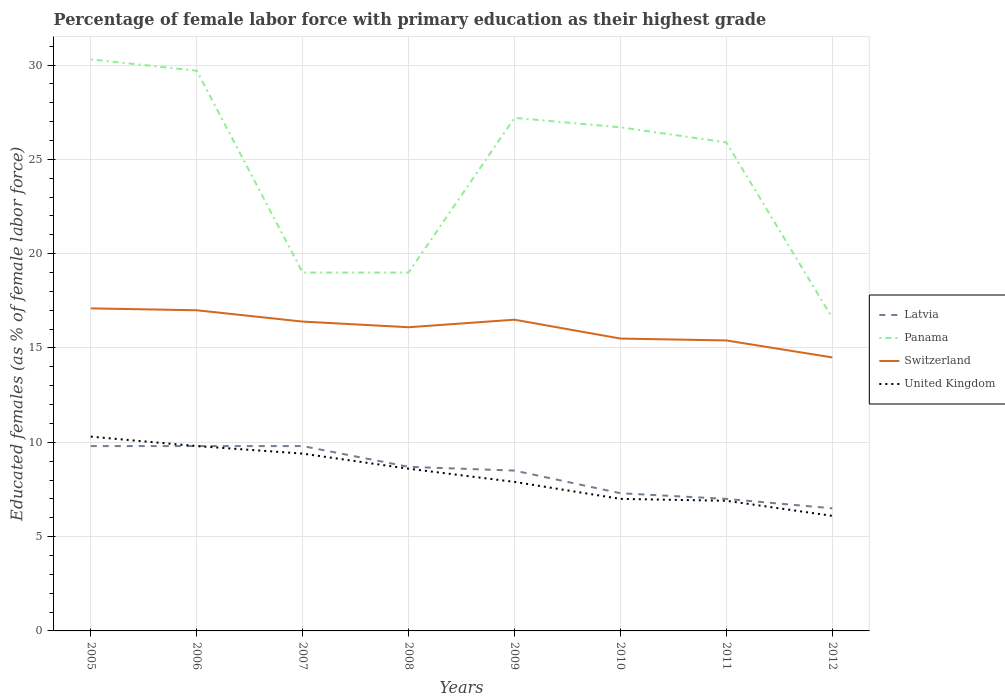How many different coloured lines are there?
Keep it short and to the point. 4. Across all years, what is the maximum percentage of female labor force with primary education in United Kingdom?
Make the answer very short. 6.1. What is the total percentage of female labor force with primary education in United Kingdom in the graph?
Your answer should be very brief. 1.2. What is the difference between the highest and the second highest percentage of female labor force with primary education in Latvia?
Keep it short and to the point. 3.3. What is the difference between the highest and the lowest percentage of female labor force with primary education in United Kingdom?
Your answer should be very brief. 4. How many lines are there?
Give a very brief answer. 4. Are the values on the major ticks of Y-axis written in scientific E-notation?
Your response must be concise. No. Does the graph contain any zero values?
Ensure brevity in your answer.  No. How are the legend labels stacked?
Your response must be concise. Vertical. What is the title of the graph?
Keep it short and to the point. Percentage of female labor force with primary education as their highest grade. Does "Honduras" appear as one of the legend labels in the graph?
Make the answer very short. No. What is the label or title of the X-axis?
Provide a short and direct response. Years. What is the label or title of the Y-axis?
Your answer should be very brief. Educated females (as % of female labor force). What is the Educated females (as % of female labor force) in Latvia in 2005?
Keep it short and to the point. 9.8. What is the Educated females (as % of female labor force) in Panama in 2005?
Offer a very short reply. 30.3. What is the Educated females (as % of female labor force) in Switzerland in 2005?
Give a very brief answer. 17.1. What is the Educated females (as % of female labor force) in United Kingdom in 2005?
Ensure brevity in your answer.  10.3. What is the Educated females (as % of female labor force) of Latvia in 2006?
Give a very brief answer. 9.8. What is the Educated females (as % of female labor force) of Panama in 2006?
Ensure brevity in your answer.  29.7. What is the Educated females (as % of female labor force) in United Kingdom in 2006?
Offer a terse response. 9.8. What is the Educated females (as % of female labor force) of Latvia in 2007?
Provide a short and direct response. 9.8. What is the Educated females (as % of female labor force) in Switzerland in 2007?
Your answer should be very brief. 16.4. What is the Educated females (as % of female labor force) of United Kingdom in 2007?
Provide a short and direct response. 9.4. What is the Educated females (as % of female labor force) in Latvia in 2008?
Ensure brevity in your answer.  8.7. What is the Educated females (as % of female labor force) of Panama in 2008?
Give a very brief answer. 19. What is the Educated females (as % of female labor force) of Switzerland in 2008?
Make the answer very short. 16.1. What is the Educated females (as % of female labor force) in United Kingdom in 2008?
Give a very brief answer. 8.6. What is the Educated females (as % of female labor force) of Latvia in 2009?
Your response must be concise. 8.5. What is the Educated females (as % of female labor force) of Panama in 2009?
Provide a succinct answer. 27.2. What is the Educated females (as % of female labor force) of United Kingdom in 2009?
Your response must be concise. 7.9. What is the Educated females (as % of female labor force) of Latvia in 2010?
Ensure brevity in your answer.  7.3. What is the Educated females (as % of female labor force) of Panama in 2010?
Your answer should be very brief. 26.7. What is the Educated females (as % of female labor force) of United Kingdom in 2010?
Your answer should be very brief. 7. What is the Educated females (as % of female labor force) of Latvia in 2011?
Offer a terse response. 7. What is the Educated females (as % of female labor force) in Panama in 2011?
Offer a terse response. 25.9. What is the Educated females (as % of female labor force) of Switzerland in 2011?
Offer a terse response. 15.4. What is the Educated females (as % of female labor force) in United Kingdom in 2011?
Provide a succinct answer. 6.9. What is the Educated females (as % of female labor force) in Panama in 2012?
Ensure brevity in your answer.  16.6. What is the Educated females (as % of female labor force) of Switzerland in 2012?
Your response must be concise. 14.5. What is the Educated females (as % of female labor force) of United Kingdom in 2012?
Keep it short and to the point. 6.1. Across all years, what is the maximum Educated females (as % of female labor force) in Latvia?
Offer a terse response. 9.8. Across all years, what is the maximum Educated females (as % of female labor force) of Panama?
Your answer should be very brief. 30.3. Across all years, what is the maximum Educated females (as % of female labor force) of Switzerland?
Your answer should be very brief. 17.1. Across all years, what is the maximum Educated females (as % of female labor force) in United Kingdom?
Give a very brief answer. 10.3. Across all years, what is the minimum Educated females (as % of female labor force) of Latvia?
Offer a terse response. 6.5. Across all years, what is the minimum Educated females (as % of female labor force) of Panama?
Offer a very short reply. 16.6. Across all years, what is the minimum Educated females (as % of female labor force) in United Kingdom?
Your response must be concise. 6.1. What is the total Educated females (as % of female labor force) in Latvia in the graph?
Keep it short and to the point. 67.4. What is the total Educated females (as % of female labor force) of Panama in the graph?
Provide a short and direct response. 194.4. What is the total Educated females (as % of female labor force) of Switzerland in the graph?
Provide a succinct answer. 128.5. What is the total Educated females (as % of female labor force) of United Kingdom in the graph?
Ensure brevity in your answer.  66. What is the difference between the Educated females (as % of female labor force) of Panama in 2005 and that in 2006?
Give a very brief answer. 0.6. What is the difference between the Educated females (as % of female labor force) in United Kingdom in 2005 and that in 2006?
Offer a very short reply. 0.5. What is the difference between the Educated females (as % of female labor force) in Panama in 2005 and that in 2007?
Provide a short and direct response. 11.3. What is the difference between the Educated females (as % of female labor force) in United Kingdom in 2005 and that in 2007?
Provide a short and direct response. 0.9. What is the difference between the Educated females (as % of female labor force) in Switzerland in 2005 and that in 2010?
Give a very brief answer. 1.6. What is the difference between the Educated females (as % of female labor force) in United Kingdom in 2005 and that in 2010?
Your answer should be compact. 3.3. What is the difference between the Educated females (as % of female labor force) in Latvia in 2005 and that in 2011?
Ensure brevity in your answer.  2.8. What is the difference between the Educated females (as % of female labor force) in Switzerland in 2005 and that in 2012?
Give a very brief answer. 2.6. What is the difference between the Educated females (as % of female labor force) in United Kingdom in 2005 and that in 2012?
Keep it short and to the point. 4.2. What is the difference between the Educated females (as % of female labor force) of Latvia in 2006 and that in 2007?
Your answer should be very brief. 0. What is the difference between the Educated females (as % of female labor force) of Panama in 2006 and that in 2007?
Offer a very short reply. 10.7. What is the difference between the Educated females (as % of female labor force) in Switzerland in 2006 and that in 2007?
Offer a very short reply. 0.6. What is the difference between the Educated females (as % of female labor force) of Latvia in 2006 and that in 2008?
Offer a terse response. 1.1. What is the difference between the Educated females (as % of female labor force) in Panama in 2006 and that in 2008?
Keep it short and to the point. 10.7. What is the difference between the Educated females (as % of female labor force) in Panama in 2006 and that in 2010?
Your answer should be compact. 3. What is the difference between the Educated females (as % of female labor force) of Switzerland in 2006 and that in 2010?
Give a very brief answer. 1.5. What is the difference between the Educated females (as % of female labor force) in Panama in 2006 and that in 2011?
Offer a terse response. 3.8. What is the difference between the Educated females (as % of female labor force) in Switzerland in 2006 and that in 2011?
Keep it short and to the point. 1.6. What is the difference between the Educated females (as % of female labor force) of Panama in 2006 and that in 2012?
Make the answer very short. 13.1. What is the difference between the Educated females (as % of female labor force) in Switzerland in 2007 and that in 2008?
Your answer should be very brief. 0.3. What is the difference between the Educated females (as % of female labor force) in United Kingdom in 2007 and that in 2008?
Your answer should be very brief. 0.8. What is the difference between the Educated females (as % of female labor force) in Panama in 2007 and that in 2009?
Provide a short and direct response. -8.2. What is the difference between the Educated females (as % of female labor force) in United Kingdom in 2007 and that in 2009?
Your answer should be very brief. 1.5. What is the difference between the Educated females (as % of female labor force) in Panama in 2007 and that in 2010?
Provide a succinct answer. -7.7. What is the difference between the Educated females (as % of female labor force) of Switzerland in 2007 and that in 2010?
Make the answer very short. 0.9. What is the difference between the Educated females (as % of female labor force) of Panama in 2007 and that in 2011?
Your response must be concise. -6.9. What is the difference between the Educated females (as % of female labor force) in Panama in 2007 and that in 2012?
Your response must be concise. 2.4. What is the difference between the Educated females (as % of female labor force) in Panama in 2008 and that in 2009?
Provide a succinct answer. -8.2. What is the difference between the Educated females (as % of female labor force) in Switzerland in 2008 and that in 2009?
Keep it short and to the point. -0.4. What is the difference between the Educated females (as % of female labor force) of United Kingdom in 2008 and that in 2009?
Your response must be concise. 0.7. What is the difference between the Educated females (as % of female labor force) of Panama in 2008 and that in 2010?
Provide a short and direct response. -7.7. What is the difference between the Educated females (as % of female labor force) of United Kingdom in 2008 and that in 2010?
Keep it short and to the point. 1.6. What is the difference between the Educated females (as % of female labor force) in Panama in 2008 and that in 2011?
Provide a short and direct response. -6.9. What is the difference between the Educated females (as % of female labor force) of Switzerland in 2008 and that in 2011?
Ensure brevity in your answer.  0.7. What is the difference between the Educated females (as % of female labor force) of Latvia in 2008 and that in 2012?
Offer a terse response. 2.2. What is the difference between the Educated females (as % of female labor force) in United Kingdom in 2008 and that in 2012?
Your response must be concise. 2.5. What is the difference between the Educated females (as % of female labor force) in Latvia in 2009 and that in 2010?
Keep it short and to the point. 1.2. What is the difference between the Educated females (as % of female labor force) of Panama in 2009 and that in 2010?
Make the answer very short. 0.5. What is the difference between the Educated females (as % of female labor force) of Switzerland in 2009 and that in 2010?
Provide a succinct answer. 1. What is the difference between the Educated females (as % of female labor force) of Panama in 2009 and that in 2011?
Your answer should be compact. 1.3. What is the difference between the Educated females (as % of female labor force) in United Kingdom in 2009 and that in 2011?
Make the answer very short. 1. What is the difference between the Educated females (as % of female labor force) in Latvia in 2009 and that in 2012?
Your response must be concise. 2. What is the difference between the Educated females (as % of female labor force) of Panama in 2009 and that in 2012?
Your response must be concise. 10.6. What is the difference between the Educated females (as % of female labor force) in United Kingdom in 2009 and that in 2012?
Make the answer very short. 1.8. What is the difference between the Educated females (as % of female labor force) in Latvia in 2010 and that in 2011?
Provide a succinct answer. 0.3. What is the difference between the Educated females (as % of female labor force) in United Kingdom in 2010 and that in 2011?
Offer a very short reply. 0.1. What is the difference between the Educated females (as % of female labor force) in Latvia in 2010 and that in 2012?
Ensure brevity in your answer.  0.8. What is the difference between the Educated females (as % of female labor force) of United Kingdom in 2010 and that in 2012?
Your answer should be compact. 0.9. What is the difference between the Educated females (as % of female labor force) of Latvia in 2011 and that in 2012?
Offer a very short reply. 0.5. What is the difference between the Educated females (as % of female labor force) of Panama in 2011 and that in 2012?
Your response must be concise. 9.3. What is the difference between the Educated females (as % of female labor force) of United Kingdom in 2011 and that in 2012?
Give a very brief answer. 0.8. What is the difference between the Educated females (as % of female labor force) in Latvia in 2005 and the Educated females (as % of female labor force) in Panama in 2006?
Make the answer very short. -19.9. What is the difference between the Educated females (as % of female labor force) in Panama in 2005 and the Educated females (as % of female labor force) in Switzerland in 2006?
Give a very brief answer. 13.3. What is the difference between the Educated females (as % of female labor force) of Panama in 2005 and the Educated females (as % of female labor force) of United Kingdom in 2006?
Your answer should be very brief. 20.5. What is the difference between the Educated females (as % of female labor force) in Latvia in 2005 and the Educated females (as % of female labor force) in Panama in 2007?
Offer a very short reply. -9.2. What is the difference between the Educated females (as % of female labor force) of Latvia in 2005 and the Educated females (as % of female labor force) of Switzerland in 2007?
Your answer should be very brief. -6.6. What is the difference between the Educated females (as % of female labor force) in Latvia in 2005 and the Educated females (as % of female labor force) in United Kingdom in 2007?
Keep it short and to the point. 0.4. What is the difference between the Educated females (as % of female labor force) in Panama in 2005 and the Educated females (as % of female labor force) in Switzerland in 2007?
Offer a terse response. 13.9. What is the difference between the Educated females (as % of female labor force) of Panama in 2005 and the Educated females (as % of female labor force) of United Kingdom in 2007?
Your answer should be compact. 20.9. What is the difference between the Educated females (as % of female labor force) of Switzerland in 2005 and the Educated females (as % of female labor force) of United Kingdom in 2007?
Make the answer very short. 7.7. What is the difference between the Educated females (as % of female labor force) in Panama in 2005 and the Educated females (as % of female labor force) in United Kingdom in 2008?
Offer a terse response. 21.7. What is the difference between the Educated females (as % of female labor force) in Switzerland in 2005 and the Educated females (as % of female labor force) in United Kingdom in 2008?
Give a very brief answer. 8.5. What is the difference between the Educated females (as % of female labor force) in Latvia in 2005 and the Educated females (as % of female labor force) in Panama in 2009?
Provide a succinct answer. -17.4. What is the difference between the Educated females (as % of female labor force) of Panama in 2005 and the Educated females (as % of female labor force) of Switzerland in 2009?
Offer a terse response. 13.8. What is the difference between the Educated females (as % of female labor force) of Panama in 2005 and the Educated females (as % of female labor force) of United Kingdom in 2009?
Make the answer very short. 22.4. What is the difference between the Educated females (as % of female labor force) in Switzerland in 2005 and the Educated females (as % of female labor force) in United Kingdom in 2009?
Offer a very short reply. 9.2. What is the difference between the Educated females (as % of female labor force) of Latvia in 2005 and the Educated females (as % of female labor force) of Panama in 2010?
Your answer should be compact. -16.9. What is the difference between the Educated females (as % of female labor force) in Latvia in 2005 and the Educated females (as % of female labor force) in Switzerland in 2010?
Keep it short and to the point. -5.7. What is the difference between the Educated females (as % of female labor force) in Latvia in 2005 and the Educated females (as % of female labor force) in United Kingdom in 2010?
Give a very brief answer. 2.8. What is the difference between the Educated females (as % of female labor force) in Panama in 2005 and the Educated females (as % of female labor force) in Switzerland in 2010?
Your answer should be compact. 14.8. What is the difference between the Educated females (as % of female labor force) of Panama in 2005 and the Educated females (as % of female labor force) of United Kingdom in 2010?
Provide a short and direct response. 23.3. What is the difference between the Educated females (as % of female labor force) of Latvia in 2005 and the Educated females (as % of female labor force) of Panama in 2011?
Your answer should be compact. -16.1. What is the difference between the Educated females (as % of female labor force) of Latvia in 2005 and the Educated females (as % of female labor force) of Switzerland in 2011?
Your answer should be compact. -5.6. What is the difference between the Educated females (as % of female labor force) of Latvia in 2005 and the Educated females (as % of female labor force) of United Kingdom in 2011?
Your answer should be very brief. 2.9. What is the difference between the Educated females (as % of female labor force) of Panama in 2005 and the Educated females (as % of female labor force) of Switzerland in 2011?
Give a very brief answer. 14.9. What is the difference between the Educated females (as % of female labor force) of Panama in 2005 and the Educated females (as % of female labor force) of United Kingdom in 2011?
Offer a very short reply. 23.4. What is the difference between the Educated females (as % of female labor force) in Latvia in 2005 and the Educated females (as % of female labor force) in Switzerland in 2012?
Your response must be concise. -4.7. What is the difference between the Educated females (as % of female labor force) in Latvia in 2005 and the Educated females (as % of female labor force) in United Kingdom in 2012?
Your answer should be compact. 3.7. What is the difference between the Educated females (as % of female labor force) in Panama in 2005 and the Educated females (as % of female labor force) in United Kingdom in 2012?
Offer a very short reply. 24.2. What is the difference between the Educated females (as % of female labor force) of Latvia in 2006 and the Educated females (as % of female labor force) of Panama in 2007?
Keep it short and to the point. -9.2. What is the difference between the Educated females (as % of female labor force) in Latvia in 2006 and the Educated females (as % of female labor force) in United Kingdom in 2007?
Provide a succinct answer. 0.4. What is the difference between the Educated females (as % of female labor force) in Panama in 2006 and the Educated females (as % of female labor force) in Switzerland in 2007?
Keep it short and to the point. 13.3. What is the difference between the Educated females (as % of female labor force) in Panama in 2006 and the Educated females (as % of female labor force) in United Kingdom in 2007?
Provide a succinct answer. 20.3. What is the difference between the Educated females (as % of female labor force) in Switzerland in 2006 and the Educated females (as % of female labor force) in United Kingdom in 2007?
Provide a succinct answer. 7.6. What is the difference between the Educated females (as % of female labor force) of Latvia in 2006 and the Educated females (as % of female labor force) of Panama in 2008?
Offer a very short reply. -9.2. What is the difference between the Educated females (as % of female labor force) of Panama in 2006 and the Educated females (as % of female labor force) of United Kingdom in 2008?
Give a very brief answer. 21.1. What is the difference between the Educated females (as % of female labor force) of Latvia in 2006 and the Educated females (as % of female labor force) of Panama in 2009?
Offer a very short reply. -17.4. What is the difference between the Educated females (as % of female labor force) in Latvia in 2006 and the Educated females (as % of female labor force) in Switzerland in 2009?
Provide a short and direct response. -6.7. What is the difference between the Educated females (as % of female labor force) in Latvia in 2006 and the Educated females (as % of female labor force) in United Kingdom in 2009?
Your response must be concise. 1.9. What is the difference between the Educated females (as % of female labor force) in Panama in 2006 and the Educated females (as % of female labor force) in Switzerland in 2009?
Provide a succinct answer. 13.2. What is the difference between the Educated females (as % of female labor force) in Panama in 2006 and the Educated females (as % of female labor force) in United Kingdom in 2009?
Ensure brevity in your answer.  21.8. What is the difference between the Educated females (as % of female labor force) in Switzerland in 2006 and the Educated females (as % of female labor force) in United Kingdom in 2009?
Provide a succinct answer. 9.1. What is the difference between the Educated females (as % of female labor force) in Latvia in 2006 and the Educated females (as % of female labor force) in Panama in 2010?
Keep it short and to the point. -16.9. What is the difference between the Educated females (as % of female labor force) in Latvia in 2006 and the Educated females (as % of female labor force) in Switzerland in 2010?
Your answer should be compact. -5.7. What is the difference between the Educated females (as % of female labor force) of Panama in 2006 and the Educated females (as % of female labor force) of Switzerland in 2010?
Provide a short and direct response. 14.2. What is the difference between the Educated females (as % of female labor force) in Panama in 2006 and the Educated females (as % of female labor force) in United Kingdom in 2010?
Your answer should be very brief. 22.7. What is the difference between the Educated females (as % of female labor force) in Switzerland in 2006 and the Educated females (as % of female labor force) in United Kingdom in 2010?
Offer a very short reply. 10. What is the difference between the Educated females (as % of female labor force) in Latvia in 2006 and the Educated females (as % of female labor force) in Panama in 2011?
Give a very brief answer. -16.1. What is the difference between the Educated females (as % of female labor force) in Latvia in 2006 and the Educated females (as % of female labor force) in United Kingdom in 2011?
Provide a short and direct response. 2.9. What is the difference between the Educated females (as % of female labor force) of Panama in 2006 and the Educated females (as % of female labor force) of United Kingdom in 2011?
Make the answer very short. 22.8. What is the difference between the Educated females (as % of female labor force) in Switzerland in 2006 and the Educated females (as % of female labor force) in United Kingdom in 2011?
Make the answer very short. 10.1. What is the difference between the Educated females (as % of female labor force) in Panama in 2006 and the Educated females (as % of female labor force) in United Kingdom in 2012?
Your answer should be very brief. 23.6. What is the difference between the Educated females (as % of female labor force) in Latvia in 2007 and the Educated females (as % of female labor force) in Switzerland in 2008?
Offer a terse response. -6.3. What is the difference between the Educated females (as % of female labor force) in Latvia in 2007 and the Educated females (as % of female labor force) in United Kingdom in 2008?
Your answer should be compact. 1.2. What is the difference between the Educated females (as % of female labor force) in Panama in 2007 and the Educated females (as % of female labor force) in Switzerland in 2008?
Offer a very short reply. 2.9. What is the difference between the Educated females (as % of female labor force) of Latvia in 2007 and the Educated females (as % of female labor force) of Panama in 2009?
Keep it short and to the point. -17.4. What is the difference between the Educated females (as % of female labor force) in Latvia in 2007 and the Educated females (as % of female labor force) in Switzerland in 2009?
Offer a very short reply. -6.7. What is the difference between the Educated females (as % of female labor force) of Switzerland in 2007 and the Educated females (as % of female labor force) of United Kingdom in 2009?
Offer a terse response. 8.5. What is the difference between the Educated females (as % of female labor force) of Latvia in 2007 and the Educated females (as % of female labor force) of Panama in 2010?
Your answer should be very brief. -16.9. What is the difference between the Educated females (as % of female labor force) of Panama in 2007 and the Educated females (as % of female labor force) of Switzerland in 2010?
Provide a succinct answer. 3.5. What is the difference between the Educated females (as % of female labor force) in Panama in 2007 and the Educated females (as % of female labor force) in United Kingdom in 2010?
Offer a very short reply. 12. What is the difference between the Educated females (as % of female labor force) of Latvia in 2007 and the Educated females (as % of female labor force) of Panama in 2011?
Make the answer very short. -16.1. What is the difference between the Educated females (as % of female labor force) of Latvia in 2007 and the Educated females (as % of female labor force) of United Kingdom in 2011?
Provide a short and direct response. 2.9. What is the difference between the Educated females (as % of female labor force) of Panama in 2007 and the Educated females (as % of female labor force) of Switzerland in 2011?
Ensure brevity in your answer.  3.6. What is the difference between the Educated females (as % of female labor force) in Latvia in 2007 and the Educated females (as % of female labor force) in United Kingdom in 2012?
Provide a succinct answer. 3.7. What is the difference between the Educated females (as % of female labor force) in Panama in 2007 and the Educated females (as % of female labor force) in Switzerland in 2012?
Your answer should be very brief. 4.5. What is the difference between the Educated females (as % of female labor force) of Latvia in 2008 and the Educated females (as % of female labor force) of Panama in 2009?
Offer a very short reply. -18.5. What is the difference between the Educated females (as % of female labor force) of Latvia in 2008 and the Educated females (as % of female labor force) of Panama in 2010?
Your answer should be very brief. -18. What is the difference between the Educated females (as % of female labor force) in Latvia in 2008 and the Educated females (as % of female labor force) in United Kingdom in 2010?
Offer a very short reply. 1.7. What is the difference between the Educated females (as % of female labor force) of Panama in 2008 and the Educated females (as % of female labor force) of Switzerland in 2010?
Offer a very short reply. 3.5. What is the difference between the Educated females (as % of female labor force) in Latvia in 2008 and the Educated females (as % of female labor force) in Panama in 2011?
Offer a very short reply. -17.2. What is the difference between the Educated females (as % of female labor force) in Latvia in 2008 and the Educated females (as % of female labor force) in Switzerland in 2011?
Your answer should be very brief. -6.7. What is the difference between the Educated females (as % of female labor force) in Latvia in 2008 and the Educated females (as % of female labor force) in United Kingdom in 2011?
Your answer should be compact. 1.8. What is the difference between the Educated females (as % of female labor force) in Panama in 2008 and the Educated females (as % of female labor force) in Switzerland in 2011?
Keep it short and to the point. 3.6. What is the difference between the Educated females (as % of female labor force) of Switzerland in 2008 and the Educated females (as % of female labor force) of United Kingdom in 2011?
Keep it short and to the point. 9.2. What is the difference between the Educated females (as % of female labor force) in Latvia in 2008 and the Educated females (as % of female labor force) in Panama in 2012?
Your response must be concise. -7.9. What is the difference between the Educated females (as % of female labor force) in Latvia in 2008 and the Educated females (as % of female labor force) in Switzerland in 2012?
Keep it short and to the point. -5.8. What is the difference between the Educated females (as % of female labor force) of Latvia in 2008 and the Educated females (as % of female labor force) of United Kingdom in 2012?
Keep it short and to the point. 2.6. What is the difference between the Educated females (as % of female labor force) of Switzerland in 2008 and the Educated females (as % of female labor force) of United Kingdom in 2012?
Ensure brevity in your answer.  10. What is the difference between the Educated females (as % of female labor force) of Latvia in 2009 and the Educated females (as % of female labor force) of Panama in 2010?
Provide a short and direct response. -18.2. What is the difference between the Educated females (as % of female labor force) in Latvia in 2009 and the Educated females (as % of female labor force) in Switzerland in 2010?
Ensure brevity in your answer.  -7. What is the difference between the Educated females (as % of female labor force) in Latvia in 2009 and the Educated females (as % of female labor force) in United Kingdom in 2010?
Provide a succinct answer. 1.5. What is the difference between the Educated females (as % of female labor force) of Panama in 2009 and the Educated females (as % of female labor force) of Switzerland in 2010?
Give a very brief answer. 11.7. What is the difference between the Educated females (as % of female labor force) in Panama in 2009 and the Educated females (as % of female labor force) in United Kingdom in 2010?
Provide a short and direct response. 20.2. What is the difference between the Educated females (as % of female labor force) of Latvia in 2009 and the Educated females (as % of female labor force) of Panama in 2011?
Ensure brevity in your answer.  -17.4. What is the difference between the Educated females (as % of female labor force) in Latvia in 2009 and the Educated females (as % of female labor force) in Switzerland in 2011?
Your answer should be very brief. -6.9. What is the difference between the Educated females (as % of female labor force) in Panama in 2009 and the Educated females (as % of female labor force) in Switzerland in 2011?
Offer a very short reply. 11.8. What is the difference between the Educated females (as % of female labor force) in Panama in 2009 and the Educated females (as % of female labor force) in United Kingdom in 2011?
Offer a very short reply. 20.3. What is the difference between the Educated females (as % of female labor force) in Switzerland in 2009 and the Educated females (as % of female labor force) in United Kingdom in 2011?
Your answer should be compact. 9.6. What is the difference between the Educated females (as % of female labor force) of Panama in 2009 and the Educated females (as % of female labor force) of United Kingdom in 2012?
Provide a short and direct response. 21.1. What is the difference between the Educated females (as % of female labor force) of Switzerland in 2009 and the Educated females (as % of female labor force) of United Kingdom in 2012?
Ensure brevity in your answer.  10.4. What is the difference between the Educated females (as % of female labor force) in Latvia in 2010 and the Educated females (as % of female labor force) in Panama in 2011?
Ensure brevity in your answer.  -18.6. What is the difference between the Educated females (as % of female labor force) in Latvia in 2010 and the Educated females (as % of female labor force) in United Kingdom in 2011?
Your answer should be compact. 0.4. What is the difference between the Educated females (as % of female labor force) of Panama in 2010 and the Educated females (as % of female labor force) of United Kingdom in 2011?
Offer a terse response. 19.8. What is the difference between the Educated females (as % of female labor force) in Latvia in 2010 and the Educated females (as % of female labor force) in Switzerland in 2012?
Offer a terse response. -7.2. What is the difference between the Educated females (as % of female labor force) of Panama in 2010 and the Educated females (as % of female labor force) of Switzerland in 2012?
Offer a terse response. 12.2. What is the difference between the Educated females (as % of female labor force) in Panama in 2010 and the Educated females (as % of female labor force) in United Kingdom in 2012?
Keep it short and to the point. 20.6. What is the difference between the Educated females (as % of female labor force) of Latvia in 2011 and the Educated females (as % of female labor force) of Switzerland in 2012?
Give a very brief answer. -7.5. What is the difference between the Educated females (as % of female labor force) in Latvia in 2011 and the Educated females (as % of female labor force) in United Kingdom in 2012?
Make the answer very short. 0.9. What is the difference between the Educated females (as % of female labor force) in Panama in 2011 and the Educated females (as % of female labor force) in Switzerland in 2012?
Give a very brief answer. 11.4. What is the difference between the Educated females (as % of female labor force) in Panama in 2011 and the Educated females (as % of female labor force) in United Kingdom in 2012?
Your answer should be very brief. 19.8. What is the difference between the Educated females (as % of female labor force) of Switzerland in 2011 and the Educated females (as % of female labor force) of United Kingdom in 2012?
Offer a terse response. 9.3. What is the average Educated females (as % of female labor force) of Latvia per year?
Offer a terse response. 8.43. What is the average Educated females (as % of female labor force) of Panama per year?
Provide a succinct answer. 24.3. What is the average Educated females (as % of female labor force) of Switzerland per year?
Your response must be concise. 16.06. What is the average Educated females (as % of female labor force) in United Kingdom per year?
Ensure brevity in your answer.  8.25. In the year 2005, what is the difference between the Educated females (as % of female labor force) in Latvia and Educated females (as % of female labor force) in Panama?
Provide a succinct answer. -20.5. In the year 2005, what is the difference between the Educated females (as % of female labor force) in Latvia and Educated females (as % of female labor force) in Switzerland?
Give a very brief answer. -7.3. In the year 2005, what is the difference between the Educated females (as % of female labor force) in Panama and Educated females (as % of female labor force) in Switzerland?
Your answer should be very brief. 13.2. In the year 2006, what is the difference between the Educated females (as % of female labor force) in Latvia and Educated females (as % of female labor force) in Panama?
Your response must be concise. -19.9. In the year 2006, what is the difference between the Educated females (as % of female labor force) of Latvia and Educated females (as % of female labor force) of Switzerland?
Your answer should be very brief. -7.2. In the year 2006, what is the difference between the Educated females (as % of female labor force) in Switzerland and Educated females (as % of female labor force) in United Kingdom?
Offer a very short reply. 7.2. In the year 2007, what is the difference between the Educated females (as % of female labor force) in Latvia and Educated females (as % of female labor force) in Panama?
Provide a short and direct response. -9.2. In the year 2007, what is the difference between the Educated females (as % of female labor force) in Panama and Educated females (as % of female labor force) in United Kingdom?
Provide a short and direct response. 9.6. In the year 2008, what is the difference between the Educated females (as % of female labor force) of Panama and Educated females (as % of female labor force) of Switzerland?
Keep it short and to the point. 2.9. In the year 2008, what is the difference between the Educated females (as % of female labor force) of Panama and Educated females (as % of female labor force) of United Kingdom?
Provide a short and direct response. 10.4. In the year 2008, what is the difference between the Educated females (as % of female labor force) in Switzerland and Educated females (as % of female labor force) in United Kingdom?
Offer a terse response. 7.5. In the year 2009, what is the difference between the Educated females (as % of female labor force) of Latvia and Educated females (as % of female labor force) of Panama?
Your answer should be compact. -18.7. In the year 2009, what is the difference between the Educated females (as % of female labor force) in Latvia and Educated females (as % of female labor force) in Switzerland?
Offer a terse response. -8. In the year 2009, what is the difference between the Educated females (as % of female labor force) in Panama and Educated females (as % of female labor force) in United Kingdom?
Your answer should be compact. 19.3. In the year 2010, what is the difference between the Educated females (as % of female labor force) in Latvia and Educated females (as % of female labor force) in Panama?
Give a very brief answer. -19.4. In the year 2011, what is the difference between the Educated females (as % of female labor force) of Latvia and Educated females (as % of female labor force) of Panama?
Make the answer very short. -18.9. In the year 2011, what is the difference between the Educated females (as % of female labor force) of Switzerland and Educated females (as % of female labor force) of United Kingdom?
Ensure brevity in your answer.  8.5. In the year 2012, what is the difference between the Educated females (as % of female labor force) of Latvia and Educated females (as % of female labor force) of Panama?
Your answer should be very brief. -10.1. What is the ratio of the Educated females (as % of female labor force) in Panama in 2005 to that in 2006?
Make the answer very short. 1.02. What is the ratio of the Educated females (as % of female labor force) of Switzerland in 2005 to that in 2006?
Provide a short and direct response. 1.01. What is the ratio of the Educated females (as % of female labor force) in United Kingdom in 2005 to that in 2006?
Give a very brief answer. 1.05. What is the ratio of the Educated females (as % of female labor force) of Panama in 2005 to that in 2007?
Make the answer very short. 1.59. What is the ratio of the Educated females (as % of female labor force) in Switzerland in 2005 to that in 2007?
Your answer should be very brief. 1.04. What is the ratio of the Educated females (as % of female labor force) in United Kingdom in 2005 to that in 2007?
Offer a very short reply. 1.1. What is the ratio of the Educated females (as % of female labor force) in Latvia in 2005 to that in 2008?
Your answer should be very brief. 1.13. What is the ratio of the Educated females (as % of female labor force) of Panama in 2005 to that in 2008?
Ensure brevity in your answer.  1.59. What is the ratio of the Educated females (as % of female labor force) of Switzerland in 2005 to that in 2008?
Provide a succinct answer. 1.06. What is the ratio of the Educated females (as % of female labor force) of United Kingdom in 2005 to that in 2008?
Provide a succinct answer. 1.2. What is the ratio of the Educated females (as % of female labor force) of Latvia in 2005 to that in 2009?
Provide a short and direct response. 1.15. What is the ratio of the Educated females (as % of female labor force) in Panama in 2005 to that in 2009?
Your response must be concise. 1.11. What is the ratio of the Educated females (as % of female labor force) of Switzerland in 2005 to that in 2009?
Provide a succinct answer. 1.04. What is the ratio of the Educated females (as % of female labor force) in United Kingdom in 2005 to that in 2009?
Make the answer very short. 1.3. What is the ratio of the Educated females (as % of female labor force) of Latvia in 2005 to that in 2010?
Offer a very short reply. 1.34. What is the ratio of the Educated females (as % of female labor force) of Panama in 2005 to that in 2010?
Ensure brevity in your answer.  1.13. What is the ratio of the Educated females (as % of female labor force) of Switzerland in 2005 to that in 2010?
Provide a short and direct response. 1.1. What is the ratio of the Educated females (as % of female labor force) of United Kingdom in 2005 to that in 2010?
Provide a short and direct response. 1.47. What is the ratio of the Educated females (as % of female labor force) in Latvia in 2005 to that in 2011?
Give a very brief answer. 1.4. What is the ratio of the Educated females (as % of female labor force) in Panama in 2005 to that in 2011?
Provide a succinct answer. 1.17. What is the ratio of the Educated females (as % of female labor force) of Switzerland in 2005 to that in 2011?
Your answer should be compact. 1.11. What is the ratio of the Educated females (as % of female labor force) in United Kingdom in 2005 to that in 2011?
Provide a short and direct response. 1.49. What is the ratio of the Educated females (as % of female labor force) in Latvia in 2005 to that in 2012?
Provide a succinct answer. 1.51. What is the ratio of the Educated females (as % of female labor force) of Panama in 2005 to that in 2012?
Your response must be concise. 1.83. What is the ratio of the Educated females (as % of female labor force) in Switzerland in 2005 to that in 2012?
Your response must be concise. 1.18. What is the ratio of the Educated females (as % of female labor force) of United Kingdom in 2005 to that in 2012?
Offer a terse response. 1.69. What is the ratio of the Educated females (as % of female labor force) in Latvia in 2006 to that in 2007?
Your answer should be compact. 1. What is the ratio of the Educated females (as % of female labor force) of Panama in 2006 to that in 2007?
Your answer should be very brief. 1.56. What is the ratio of the Educated females (as % of female labor force) in Switzerland in 2006 to that in 2007?
Give a very brief answer. 1.04. What is the ratio of the Educated females (as % of female labor force) in United Kingdom in 2006 to that in 2007?
Offer a very short reply. 1.04. What is the ratio of the Educated females (as % of female labor force) of Latvia in 2006 to that in 2008?
Ensure brevity in your answer.  1.13. What is the ratio of the Educated females (as % of female labor force) of Panama in 2006 to that in 2008?
Your answer should be very brief. 1.56. What is the ratio of the Educated females (as % of female labor force) of Switzerland in 2006 to that in 2008?
Provide a short and direct response. 1.06. What is the ratio of the Educated females (as % of female labor force) in United Kingdom in 2006 to that in 2008?
Your answer should be very brief. 1.14. What is the ratio of the Educated females (as % of female labor force) in Latvia in 2006 to that in 2009?
Make the answer very short. 1.15. What is the ratio of the Educated females (as % of female labor force) of Panama in 2006 to that in 2009?
Offer a very short reply. 1.09. What is the ratio of the Educated females (as % of female labor force) in Switzerland in 2006 to that in 2009?
Your answer should be compact. 1.03. What is the ratio of the Educated females (as % of female labor force) in United Kingdom in 2006 to that in 2009?
Ensure brevity in your answer.  1.24. What is the ratio of the Educated females (as % of female labor force) in Latvia in 2006 to that in 2010?
Offer a very short reply. 1.34. What is the ratio of the Educated females (as % of female labor force) of Panama in 2006 to that in 2010?
Your answer should be very brief. 1.11. What is the ratio of the Educated females (as % of female labor force) in Switzerland in 2006 to that in 2010?
Provide a short and direct response. 1.1. What is the ratio of the Educated females (as % of female labor force) of Panama in 2006 to that in 2011?
Offer a very short reply. 1.15. What is the ratio of the Educated females (as % of female labor force) in Switzerland in 2006 to that in 2011?
Keep it short and to the point. 1.1. What is the ratio of the Educated females (as % of female labor force) of United Kingdom in 2006 to that in 2011?
Your answer should be very brief. 1.42. What is the ratio of the Educated females (as % of female labor force) of Latvia in 2006 to that in 2012?
Offer a very short reply. 1.51. What is the ratio of the Educated females (as % of female labor force) in Panama in 2006 to that in 2012?
Your answer should be very brief. 1.79. What is the ratio of the Educated females (as % of female labor force) in Switzerland in 2006 to that in 2012?
Provide a short and direct response. 1.17. What is the ratio of the Educated females (as % of female labor force) in United Kingdom in 2006 to that in 2012?
Provide a succinct answer. 1.61. What is the ratio of the Educated females (as % of female labor force) in Latvia in 2007 to that in 2008?
Your answer should be very brief. 1.13. What is the ratio of the Educated females (as % of female labor force) of Switzerland in 2007 to that in 2008?
Ensure brevity in your answer.  1.02. What is the ratio of the Educated females (as % of female labor force) of United Kingdom in 2007 to that in 2008?
Make the answer very short. 1.09. What is the ratio of the Educated females (as % of female labor force) of Latvia in 2007 to that in 2009?
Your response must be concise. 1.15. What is the ratio of the Educated females (as % of female labor force) in Panama in 2007 to that in 2009?
Provide a short and direct response. 0.7. What is the ratio of the Educated females (as % of female labor force) of United Kingdom in 2007 to that in 2009?
Your response must be concise. 1.19. What is the ratio of the Educated females (as % of female labor force) of Latvia in 2007 to that in 2010?
Offer a very short reply. 1.34. What is the ratio of the Educated females (as % of female labor force) in Panama in 2007 to that in 2010?
Your answer should be compact. 0.71. What is the ratio of the Educated females (as % of female labor force) of Switzerland in 2007 to that in 2010?
Give a very brief answer. 1.06. What is the ratio of the Educated females (as % of female labor force) of United Kingdom in 2007 to that in 2010?
Your answer should be very brief. 1.34. What is the ratio of the Educated females (as % of female labor force) in Latvia in 2007 to that in 2011?
Your answer should be compact. 1.4. What is the ratio of the Educated females (as % of female labor force) in Panama in 2007 to that in 2011?
Offer a terse response. 0.73. What is the ratio of the Educated females (as % of female labor force) of Switzerland in 2007 to that in 2011?
Offer a terse response. 1.06. What is the ratio of the Educated females (as % of female labor force) of United Kingdom in 2007 to that in 2011?
Your response must be concise. 1.36. What is the ratio of the Educated females (as % of female labor force) of Latvia in 2007 to that in 2012?
Provide a succinct answer. 1.51. What is the ratio of the Educated females (as % of female labor force) of Panama in 2007 to that in 2012?
Keep it short and to the point. 1.14. What is the ratio of the Educated females (as % of female labor force) in Switzerland in 2007 to that in 2012?
Make the answer very short. 1.13. What is the ratio of the Educated females (as % of female labor force) in United Kingdom in 2007 to that in 2012?
Provide a short and direct response. 1.54. What is the ratio of the Educated females (as % of female labor force) in Latvia in 2008 to that in 2009?
Provide a succinct answer. 1.02. What is the ratio of the Educated females (as % of female labor force) in Panama in 2008 to that in 2009?
Your answer should be very brief. 0.7. What is the ratio of the Educated females (as % of female labor force) in Switzerland in 2008 to that in 2009?
Ensure brevity in your answer.  0.98. What is the ratio of the Educated females (as % of female labor force) of United Kingdom in 2008 to that in 2009?
Keep it short and to the point. 1.09. What is the ratio of the Educated females (as % of female labor force) in Latvia in 2008 to that in 2010?
Your answer should be very brief. 1.19. What is the ratio of the Educated females (as % of female labor force) in Panama in 2008 to that in 2010?
Provide a succinct answer. 0.71. What is the ratio of the Educated females (as % of female labor force) of Switzerland in 2008 to that in 2010?
Your answer should be very brief. 1.04. What is the ratio of the Educated females (as % of female labor force) in United Kingdom in 2008 to that in 2010?
Ensure brevity in your answer.  1.23. What is the ratio of the Educated females (as % of female labor force) of Latvia in 2008 to that in 2011?
Give a very brief answer. 1.24. What is the ratio of the Educated females (as % of female labor force) in Panama in 2008 to that in 2011?
Offer a terse response. 0.73. What is the ratio of the Educated females (as % of female labor force) in Switzerland in 2008 to that in 2011?
Your answer should be compact. 1.05. What is the ratio of the Educated females (as % of female labor force) of United Kingdom in 2008 to that in 2011?
Your answer should be compact. 1.25. What is the ratio of the Educated females (as % of female labor force) in Latvia in 2008 to that in 2012?
Give a very brief answer. 1.34. What is the ratio of the Educated females (as % of female labor force) of Panama in 2008 to that in 2012?
Give a very brief answer. 1.14. What is the ratio of the Educated females (as % of female labor force) of Switzerland in 2008 to that in 2012?
Make the answer very short. 1.11. What is the ratio of the Educated females (as % of female labor force) of United Kingdom in 2008 to that in 2012?
Your answer should be very brief. 1.41. What is the ratio of the Educated females (as % of female labor force) of Latvia in 2009 to that in 2010?
Ensure brevity in your answer.  1.16. What is the ratio of the Educated females (as % of female labor force) of Panama in 2009 to that in 2010?
Provide a short and direct response. 1.02. What is the ratio of the Educated females (as % of female labor force) in Switzerland in 2009 to that in 2010?
Offer a very short reply. 1.06. What is the ratio of the Educated females (as % of female labor force) in United Kingdom in 2009 to that in 2010?
Make the answer very short. 1.13. What is the ratio of the Educated females (as % of female labor force) of Latvia in 2009 to that in 2011?
Your answer should be very brief. 1.21. What is the ratio of the Educated females (as % of female labor force) in Panama in 2009 to that in 2011?
Ensure brevity in your answer.  1.05. What is the ratio of the Educated females (as % of female labor force) of Switzerland in 2009 to that in 2011?
Your answer should be compact. 1.07. What is the ratio of the Educated females (as % of female labor force) of United Kingdom in 2009 to that in 2011?
Make the answer very short. 1.14. What is the ratio of the Educated females (as % of female labor force) of Latvia in 2009 to that in 2012?
Your response must be concise. 1.31. What is the ratio of the Educated females (as % of female labor force) of Panama in 2009 to that in 2012?
Your answer should be very brief. 1.64. What is the ratio of the Educated females (as % of female labor force) of Switzerland in 2009 to that in 2012?
Provide a succinct answer. 1.14. What is the ratio of the Educated females (as % of female labor force) in United Kingdom in 2009 to that in 2012?
Your response must be concise. 1.3. What is the ratio of the Educated females (as % of female labor force) of Latvia in 2010 to that in 2011?
Give a very brief answer. 1.04. What is the ratio of the Educated females (as % of female labor force) in Panama in 2010 to that in 2011?
Make the answer very short. 1.03. What is the ratio of the Educated females (as % of female labor force) of United Kingdom in 2010 to that in 2011?
Give a very brief answer. 1.01. What is the ratio of the Educated females (as % of female labor force) of Latvia in 2010 to that in 2012?
Offer a very short reply. 1.12. What is the ratio of the Educated females (as % of female labor force) of Panama in 2010 to that in 2012?
Your answer should be very brief. 1.61. What is the ratio of the Educated females (as % of female labor force) in Switzerland in 2010 to that in 2012?
Your response must be concise. 1.07. What is the ratio of the Educated females (as % of female labor force) of United Kingdom in 2010 to that in 2012?
Give a very brief answer. 1.15. What is the ratio of the Educated females (as % of female labor force) in Panama in 2011 to that in 2012?
Offer a terse response. 1.56. What is the ratio of the Educated females (as % of female labor force) of Switzerland in 2011 to that in 2012?
Give a very brief answer. 1.06. What is the ratio of the Educated females (as % of female labor force) of United Kingdom in 2011 to that in 2012?
Your answer should be very brief. 1.13. What is the difference between the highest and the second highest Educated females (as % of female labor force) of Latvia?
Give a very brief answer. 0. What is the difference between the highest and the second highest Educated females (as % of female labor force) in Panama?
Your response must be concise. 0.6. What is the difference between the highest and the second highest Educated females (as % of female labor force) in United Kingdom?
Your answer should be compact. 0.5. What is the difference between the highest and the lowest Educated females (as % of female labor force) of Latvia?
Keep it short and to the point. 3.3. What is the difference between the highest and the lowest Educated females (as % of female labor force) of Panama?
Your answer should be compact. 13.7. What is the difference between the highest and the lowest Educated females (as % of female labor force) of Switzerland?
Keep it short and to the point. 2.6. 